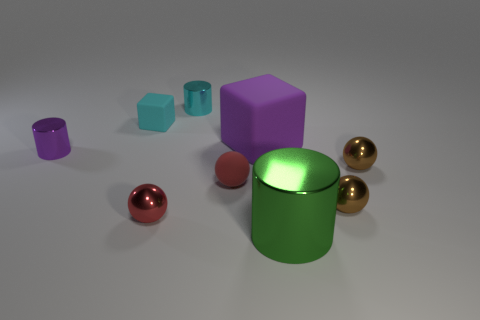Add 1 cyan rubber objects. How many objects exist? 10 Subtract all big green shiny cylinders. How many cylinders are left? 2 Subtract all purple cubes. How many cubes are left? 1 Add 9 green shiny cylinders. How many green shiny cylinders exist? 10 Subtract 1 purple cubes. How many objects are left? 8 Subtract all cylinders. How many objects are left? 6 Subtract 3 cylinders. How many cylinders are left? 0 Subtract all green cylinders. Subtract all cyan blocks. How many cylinders are left? 2 Subtract all brown spheres. How many blue cylinders are left? 0 Subtract all small purple rubber objects. Subtract all small balls. How many objects are left? 5 